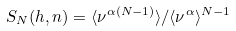Convert formula to latex. <formula><loc_0><loc_0><loc_500><loc_500>S _ { N } ( h , n ) = \langle \nu ^ { \alpha ( N - 1 ) } \rangle / \langle \nu ^ { \alpha } \rangle ^ { N - 1 }</formula> 